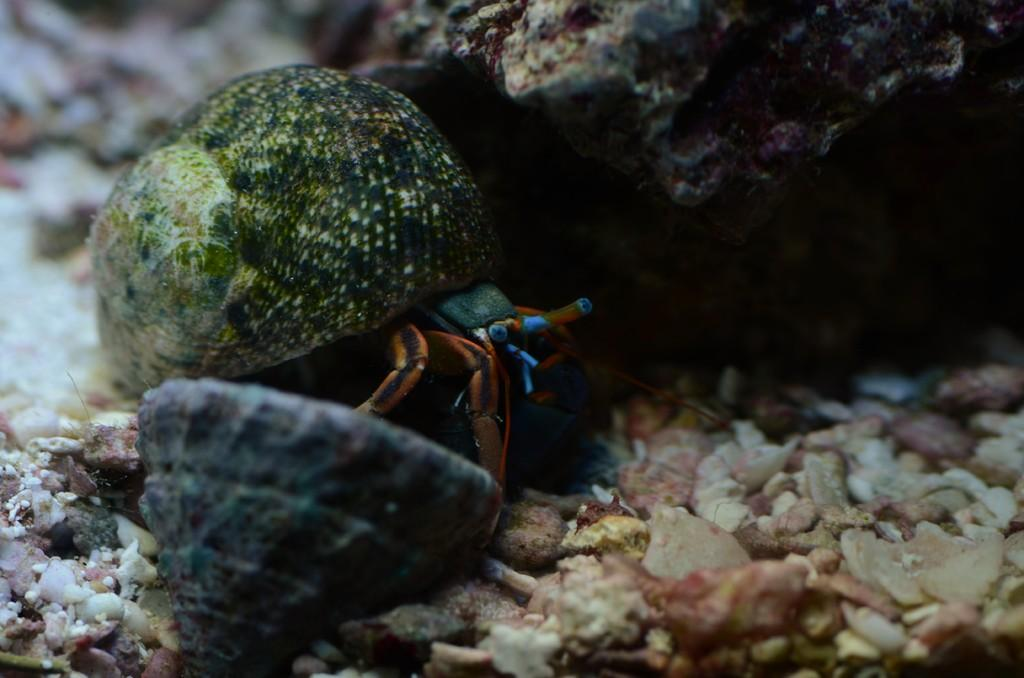What type of animal is present in the image? There is a crab in the image. What other objects can be seen in the image? There are shells and stones visible in the image. How much money is the crab holding in the image? The crab is not holding any money in the image; it is a crustacean and does not have the ability to hold money. 